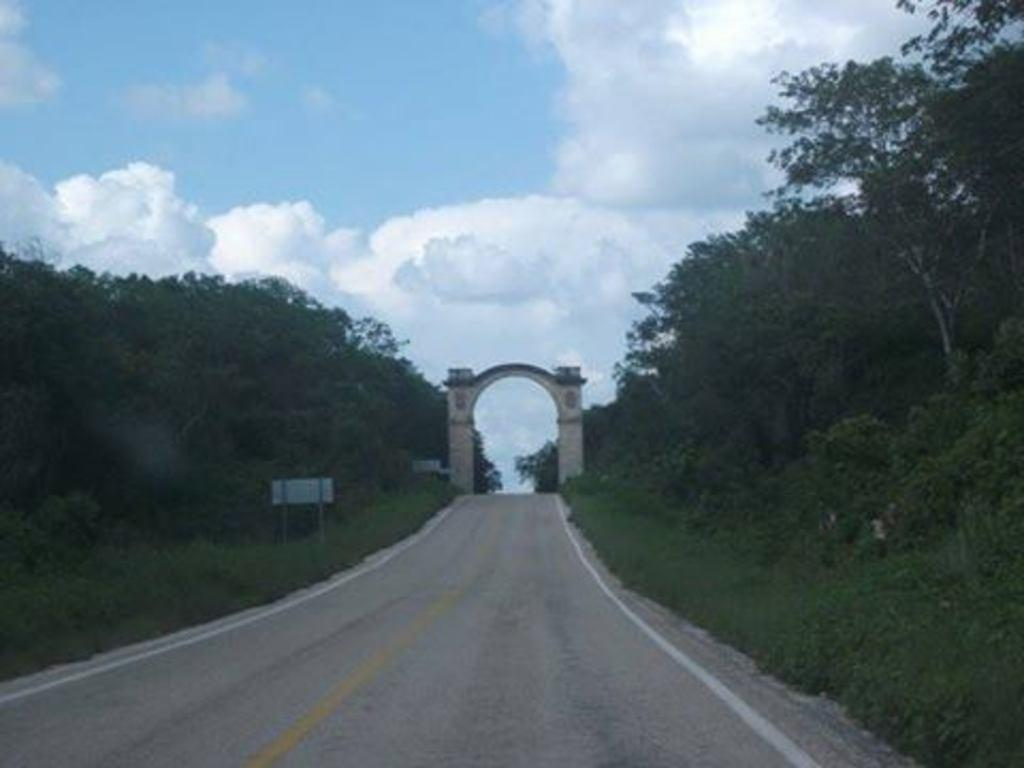What type of pathway is visible in the image? There is a road in the image. What structure can be seen above the road? There is an arch in the image. What type of vegetation is present beside the road? Grass and plants are visible beside the road. What object is placed beside the road? There is a board beside the road. What type of natural feature is present in the image? A group of trees is present in the image. What is visible at the top of the image? The sky is visible at the top of the image. What type of ball is being used to control the pest in the image? There is no ball or pest present in the image. What angle is the arch leaning at in the image? The arch is not leaning at any angle in the image; it is a stationary structure. 